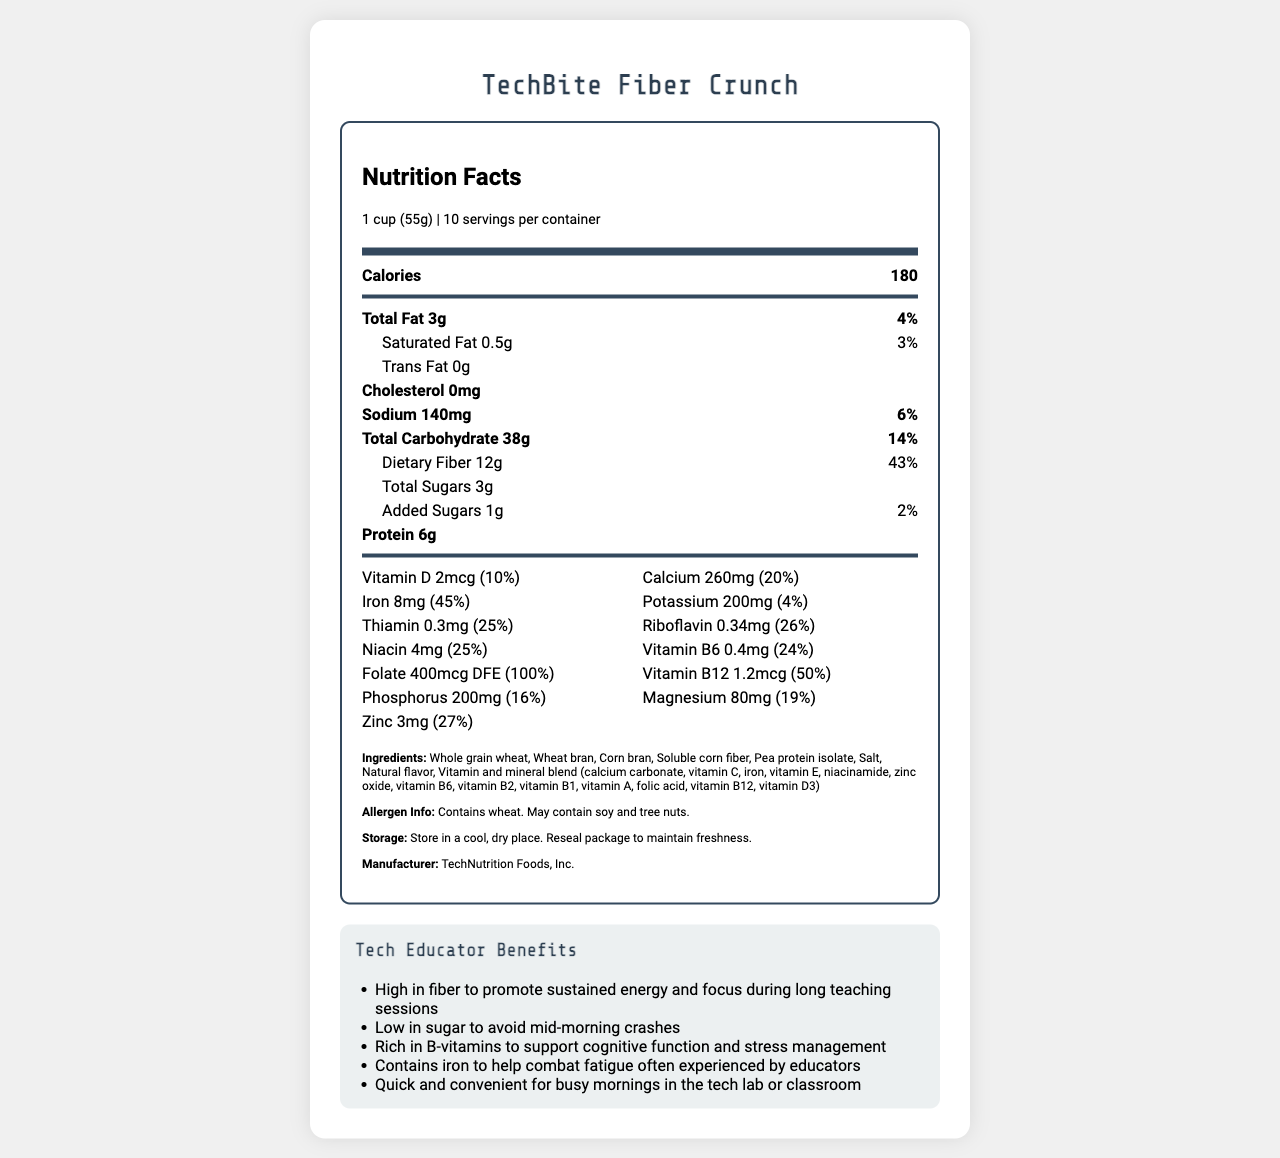what is the serving size for TechBite Fiber Crunch? The serving size is stated at the beginning of the document under the Nutrition Facts label header.
Answer: 1 cup (55g) how many servings per container are there? The servings per container are noted right below the serving size on the document.
Answer: 10 what is the total fat content per serving? The total fat content per serving is listed in the main nutrient section of the Nutrition Facts.
Answer: 3g how many grams of dietary fiber are there per serving? The amount of dietary fiber per serving is specified under the Total Carbohydrate section.
Answer: 12g what is the protein content in TechBite Fiber Crunch? The protein content is listed in the main nutrient section.
Answer: 6g how much calcium is in one serving, according to the daily value percentage? A. 10% B. 20% C. 30% D. 40% The daily value percentage for calcium is provided in the vitamins section: 20%.
Answer: B which of the following is NOT an ingredient in TechBite Fiber Crunch? A. Whole grain wheat B. Corn bran C. Honey D. Pea protein isolate The ingredients list does not include honey.
Answer: C is there any cholesterol in TechBite Fiber Crunch? The cholesterol content is stated as 0mg in the main nutrient section.
Answer: No is the cereal suitable for people with a wheat allergy? The allergen information clearly states that the cereal contains wheat.
Answer: No summarize the main benefits of TechBite Fiber Crunch for tech educators. The document highlights that this cereal supports steady energy levels, cognitive function, and combats fatigue, making it suitable for tech educators with busy schedules.
Answer: TechBite Fiber Crunch is designed for busy tech educators, offering high fiber for sustained energy, low sugar to avoid crashes, rich B-vitamins for cognitive function and stress management, and iron to fight fatigue. It is quick and convenient for busy mornings. what is the iron content per serving? The iron content is specified both in milligrams and as a percentage of the daily value in the vitamins section.
Answer: 8mg (45% daily value) does the document provide cooking instructions? The document provides suggested use instructions but does not specify any cooking instructions.
Answer: No what is the recommended storage condition for TechBite Fiber Crunch? The storage instructions are clearly mentioned at the end of the ingredients section.
Answer: Store in a cool, dry place. Reseal package to maintain freshness. which vitamins in TechBite Fiber Crunch contribute to 100% of the daily requirement? The folate information specifies that it meets 100% of the daily value.
Answer: Folate (400mcg DFE) what is the total carbohydrate content, including dietary fiber and sugars? The total carbohydrate content is available under the Total Carbohydrate section.
Answer: 38g how many added sugars are in TechBite Fiber Crunch? The added sugars are clearly listed under the Total Sugars section with a daily value of 2%.
Answer: 1g who manufactures TechBite Fiber Crunch? The manufacturer is mentioned at the end of the ingredients section.
Answer: TechNutrition Foods, Inc. assess if TechBite Fiber Crunch could be beneficial for a tech educator looking to manage stress and explain why. The tech educator benefits section highlights that B-vitamins in the cereal help with stress management.
Answer: Yes, because it is rich in B-vitamins which support cognitive function and stress management 